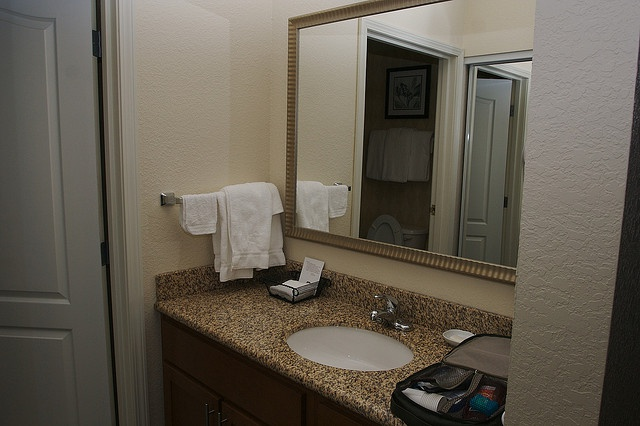Describe the objects in this image and their specific colors. I can see sink in gray tones and toilet in gray and black tones in this image. 